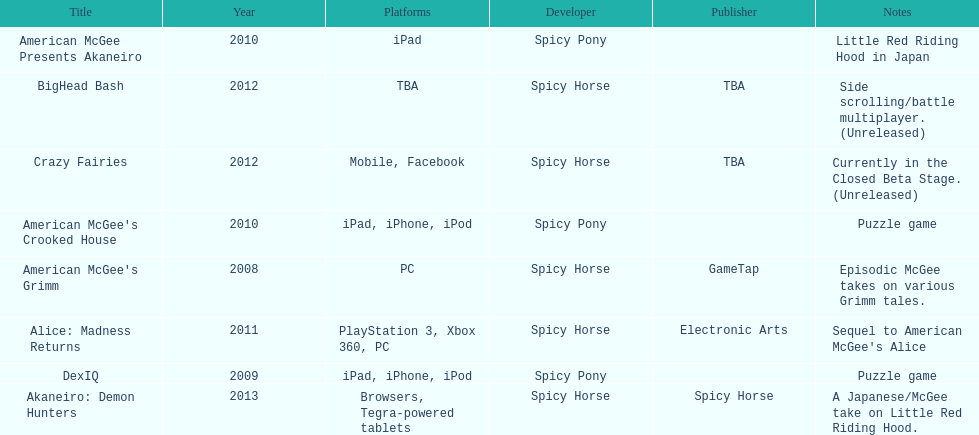What is the first title on this chart? American McGee's Grimm. 